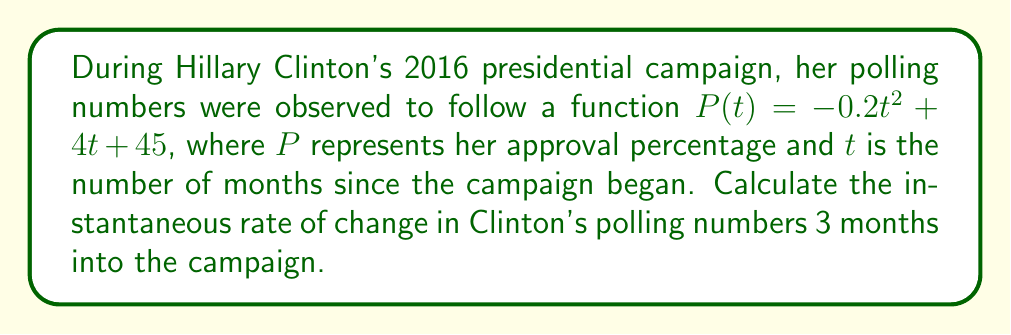Provide a solution to this math problem. To find the instantaneous rate of change at a specific point, we need to calculate the derivative of the function $P(t)$ and then evaluate it at $t = 3$.

Step 1: Find the derivative of $P(t)$
$$P(t) = -0.2t^2 + 4t + 45$$
$$P'(t) = -0.4t + 4$$

Step 2: Evaluate $P'(t)$ at $t = 3$
$$P'(3) = -0.4(3) + 4$$
$$P'(3) = -1.2 + 4$$
$$P'(3) = 2.8$$

The instantaneous rate of change at $t = 3$ is 2.8 percentage points per month.
Answer: 2.8 percentage points/month 